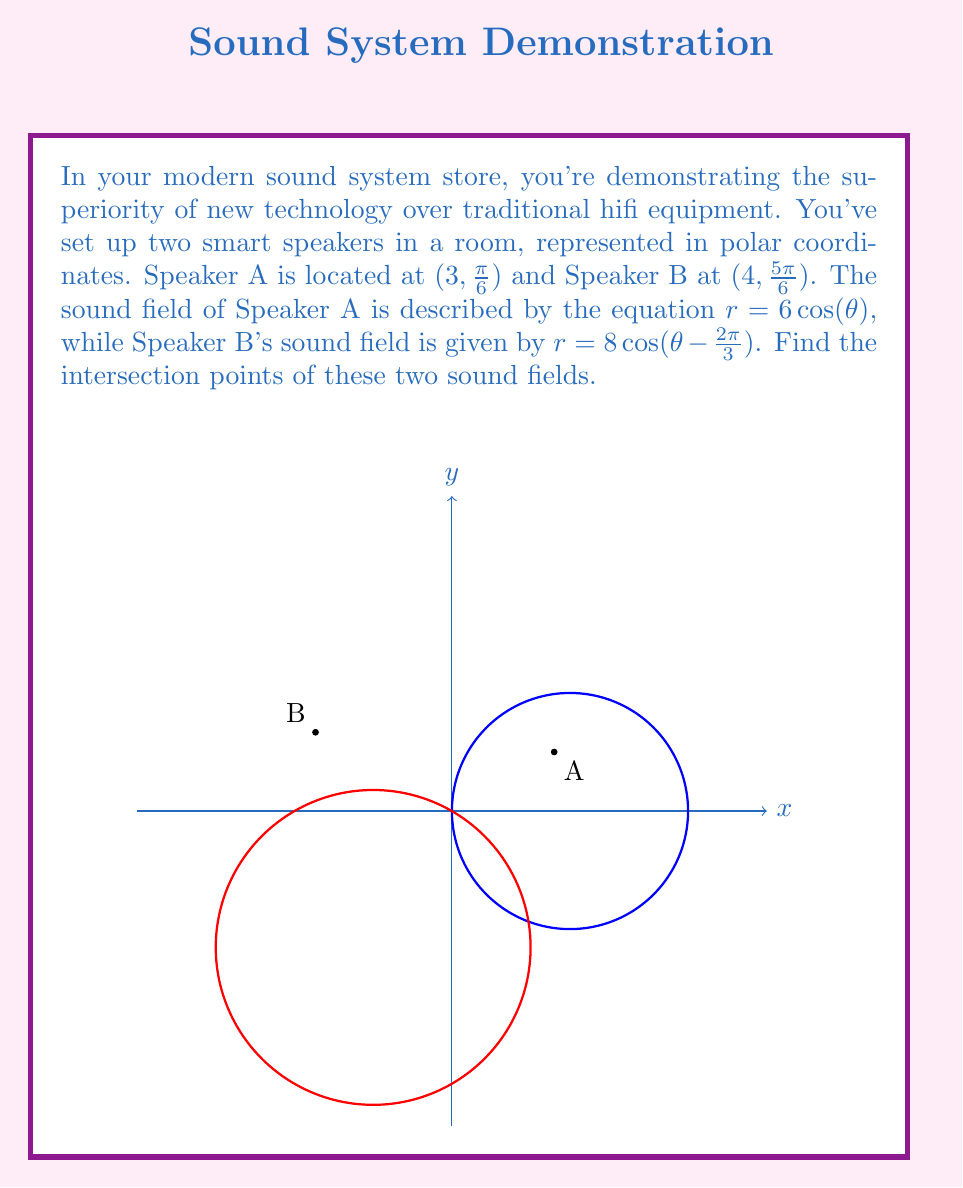Provide a solution to this math problem. To find the intersection points, we need to solve the system of equations:

$$r = 6\cos(\theta)$$
$$r = 8\cos(\theta - \frac{2\pi}{3})$$

Step 1: Equate the two equations
$$6\cos(\theta) = 8\cos(\theta - \frac{2\pi}{3})$$

Step 2: Use the trigonometric identity for the cosine of a difference
$$6\cos(\theta) = 8(\cos(\theta)\cos(\frac{2\pi}{3}) + \sin(\theta)\sin(\frac{2\pi}{3}))$$

Step 3: Simplify, knowing that $\cos(\frac{2\pi}{3}) = -\frac{1}{2}$ and $\sin(\frac{2\pi}{3}) = \frac{\sqrt{3}}{2}$
$$6\cos(\theta) = 8(-\frac{1}{2}\cos(\theta) + \frac{\sqrt{3}}{2}\sin(\theta))$$

Step 4: Rearrange terms
$$6\cos(\theta) + 4\cos(\theta) = 4\sqrt{3}\sin(\theta)$$
$$10\cos(\theta) = 4\sqrt{3}\sin(\theta)$$

Step 5: Divide both sides by $\cos(\theta)$ (assuming $\cos(\theta) \neq 0$)
$$10 = 4\sqrt{3}\tan(\theta)$$

Step 6: Solve for $\theta$
$$\tan(\theta) = \frac{5\sqrt{3}}{6}$$
$$\theta = \arctan(\frac{5\sqrt{3}}{6}) \approx 1.2490$$

The second solution is $\theta + \pi \approx 4.3906$

Step 7: Find $r$ for each $\theta$
For $\theta \approx 1.2490$: $r = 6\cos(1.2490) \approx 3.4641$
For $\theta \approx 4.3906$: $r = 6\cos(4.3906) \approx -3.4641$

Therefore, the intersection points in polar coordinates are approximately:
$(3.4641, 1.2490)$ and $(3.4641, 4.3906)$
Answer: $(3.4641, 1.2490)$ and $(3.4641, 4.3906)$ 